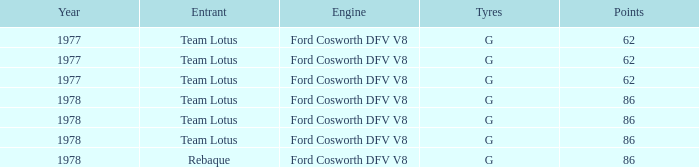What is the Motor that has a Focuses bigger than 62, and a Participant of rebaque? Ford Cosworth DFV V8. 